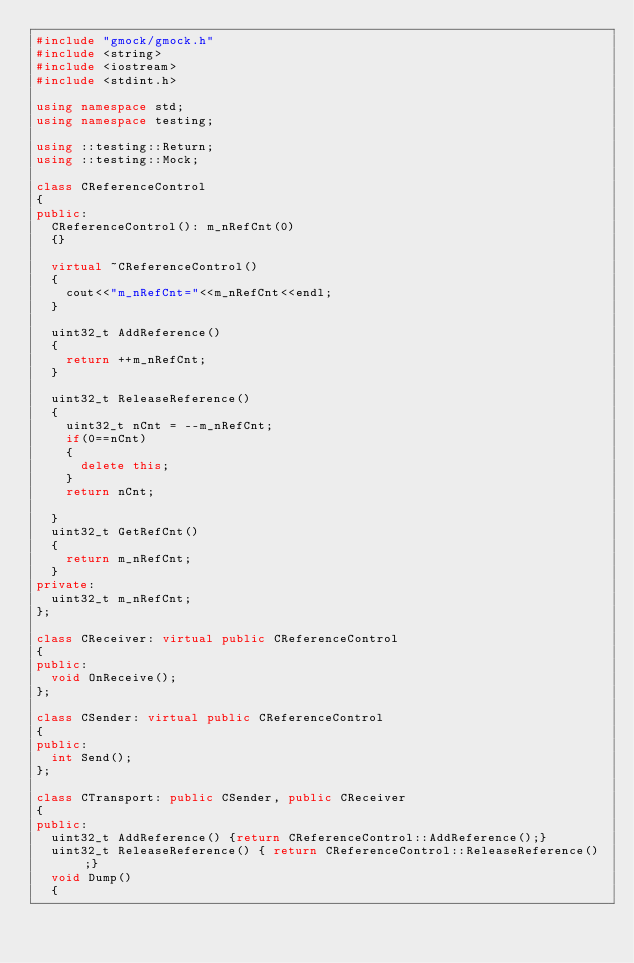Convert code to text. <code><loc_0><loc_0><loc_500><loc_500><_C++_>#include "gmock/gmock.h"
#include <string>
#include <iostream>
#include <stdint.h>

using namespace std;
using namespace testing;

using ::testing::Return;
using ::testing::Mock;

class CReferenceControl
{
public:
	CReferenceControl(): m_nRefCnt(0)
	{}

	virtual ~CReferenceControl()
	{
		cout<<"m_nRefCnt="<<m_nRefCnt<<endl;
	}

	uint32_t AddReference() 
	{
		return ++m_nRefCnt;
	}

	uint32_t ReleaseReference()
	{
		uint32_t nCnt = --m_nRefCnt;
		if(0==nCnt) 
		{
			delete this;
		} 
		return nCnt;
		
	}	
	uint32_t GetRefCnt()
	{
		return m_nRefCnt;
	}
private:
	uint32_t m_nRefCnt;
};

class CReceiver: virtual public CReferenceControl
{
public:
	void OnReceive();
};

class CSender: virtual public CReferenceControl
{
public:
	int Send();
};

class CTransport: public CSender, public CReceiver
{
public:
	uint32_t AddReference() {return CReferenceControl::AddReference();}
	uint32_t ReleaseReference() { return CReferenceControl::ReleaseReference();}
	void Dump() 
	{</code> 